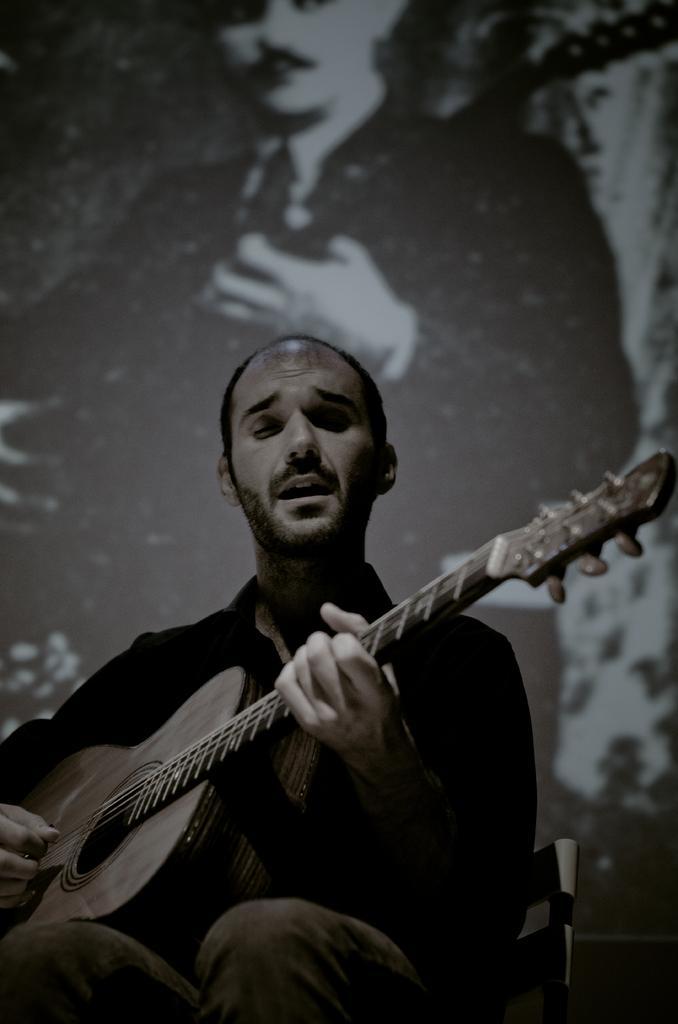In one or two sentences, can you explain what this image depicts? This man is sitting and playing guitar. A picture on wall. 